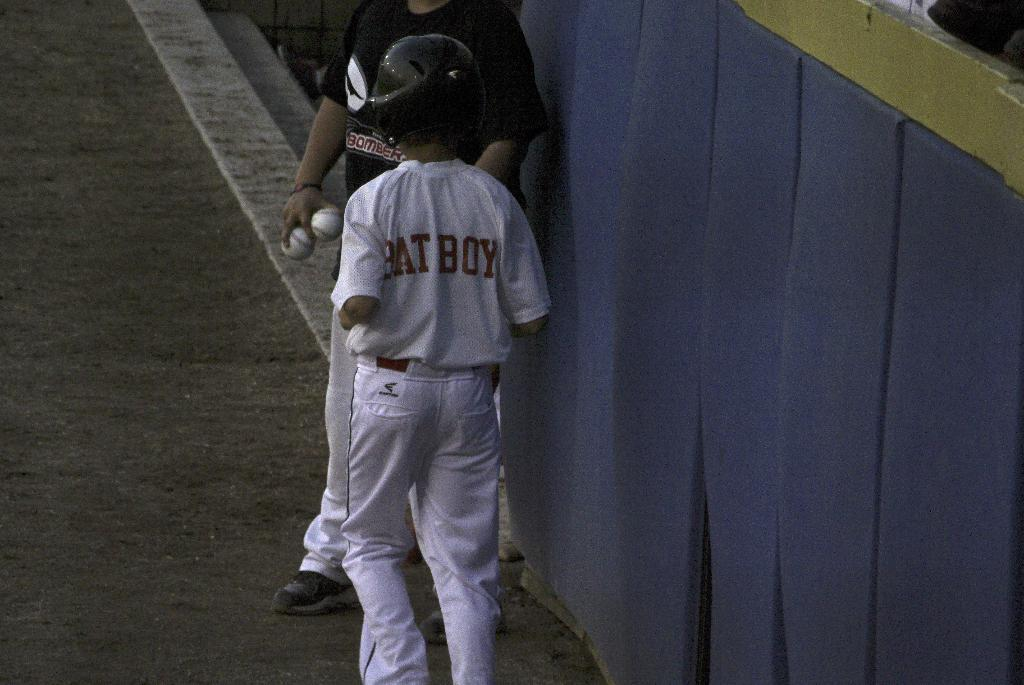<image>
Provide a brief description of the given image. a bat boy that is standing on the field 